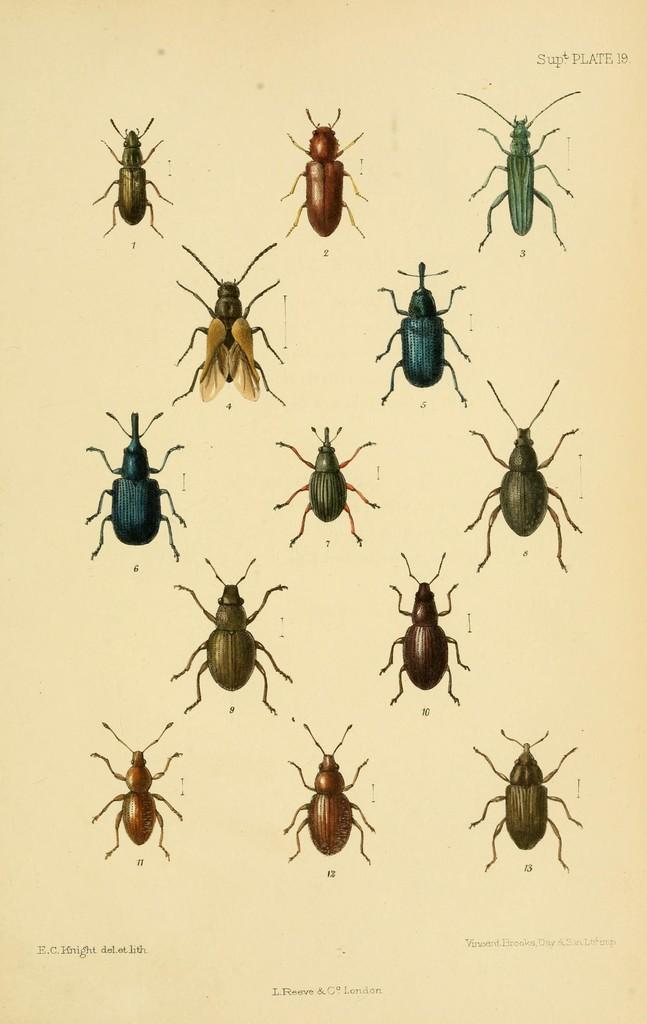What is the main subject of the drawing in the image? The drawing depicts a group of insects. What material is the drawing on? The drawing is on a paper. What type of knowledge can be gained from the governor in the image? There is no governor present in the image, and therefore no knowledge can be gained from one. 